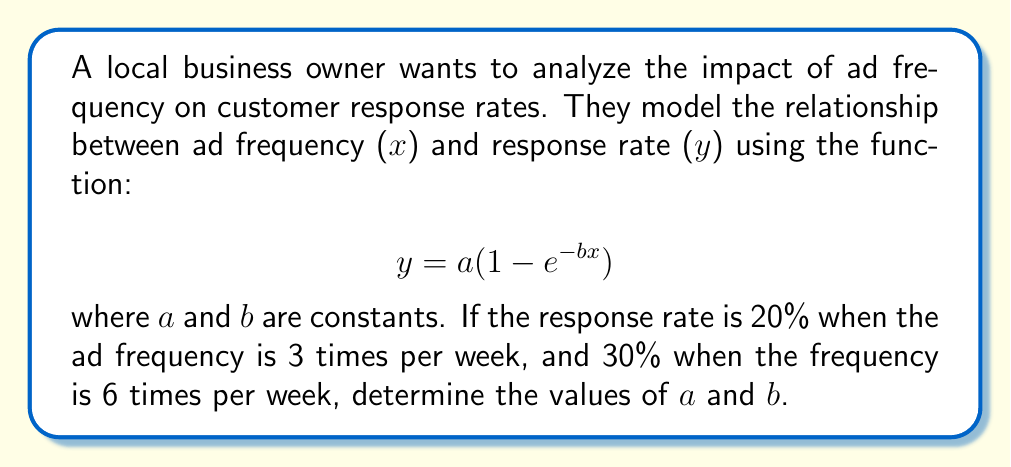Help me with this question. 1) We have two data points:
   When $x = 3$, $y = 0.20$
   When $x = 6$, $y = 0.30$

2) Let's substitute these into our equation:
   $0.20 = a(1 - e^{-3b})$  (Equation 1)
   $0.30 = a(1 - e^{-6b})$  (Equation 2)

3) Divide Equation 2 by Equation 1:
   $\frac{0.30}{0.20} = \frac{1 - e^{-6b}}{1 - e^{-3b}}$

4) Simplify:
   $1.5 = \frac{1 - e^{-6b}}{1 - e^{-3b}}$

5) Let $u = e^{-3b}$. Then $e^{-6b} = u^2$. Substitute:
   $1.5 = \frac{1 - u^2}{1 - u}$

6) Solve this equation:
   $1.5 - 1.5u = 1 - u^2$
   $u^2 - 0.5u - 0.5 = 0$

7) Use the quadratic formula to solve for $u$:
   $u = \frac{0.5 \pm \sqrt{0.25 + 2}}{2} = \frac{0.5 \pm 1.5811}{2}$

8) Take the positive root (as $u = e^{-3b}$ must be positive):
   $u = 1.0406$

9) Now we can find $b$:
   $e^{-3b} = 1.0406$
   $-3b = \ln(1.0406)$
   $b = -\frac{\ln(1.0406)}{3} = 0.0132$

10) Substitute this back into Equation 1 to find $a$:
    $0.20 = a(1 - e^{-3(0.0132)})$
    $0.20 = a(1 - 0.9612)$
    $a = \frac{0.20}{0.0388} = 5.1546$
Answer: $a \approx 5.1546$, $b \approx 0.0132$ 